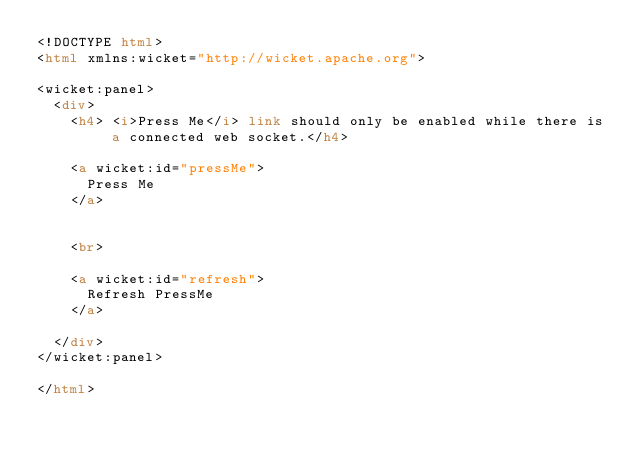Convert code to text. <code><loc_0><loc_0><loc_500><loc_500><_HTML_><!DOCTYPE html>
<html xmlns:wicket="http://wicket.apache.org">

<wicket:panel>
	<div>
		<h4> <i>Press Me</i> link should only be enabled while there is a connected web socket.</h4>

		<a wicket:id="pressMe">
			Press Me
		</a>


		<br>

		<a wicket:id="refresh">
			Refresh PressMe
		</a>

	</div>
</wicket:panel>

</html>

</code> 